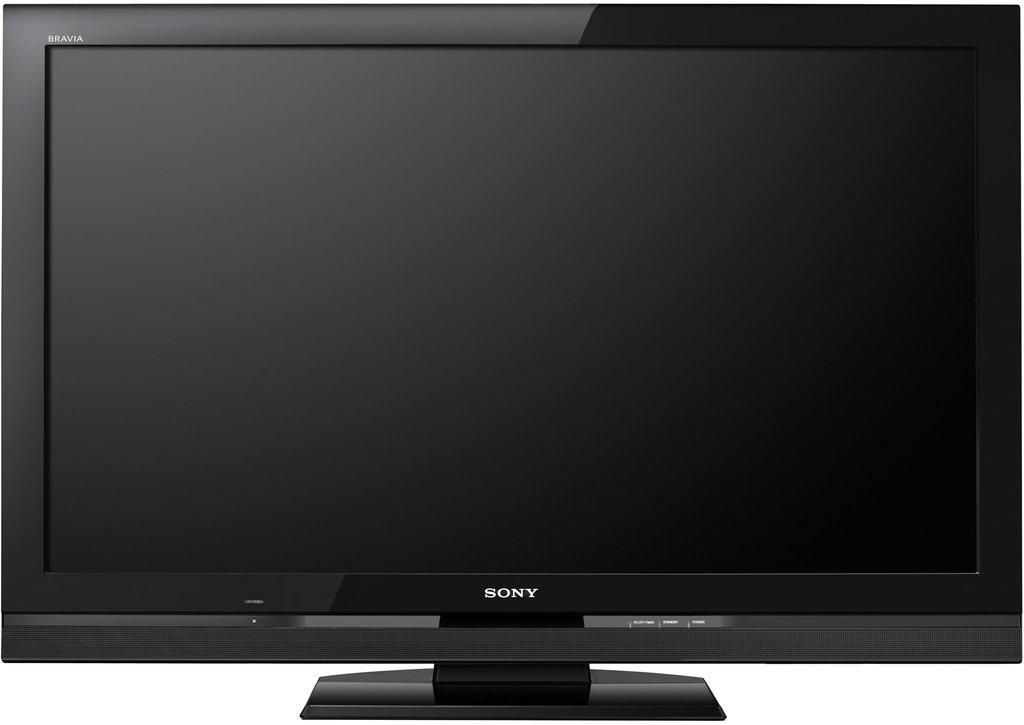What is the color of the television in the image? The television is black in color. What brand is the television in the image? The television is a Sony brand. What type of attraction can be seen in the wilderness in the image? There is no attraction or wilderness present in the image; it features a black Sony television. How many mice are visible on the television in the image? There are no mice present on the television in the image. 